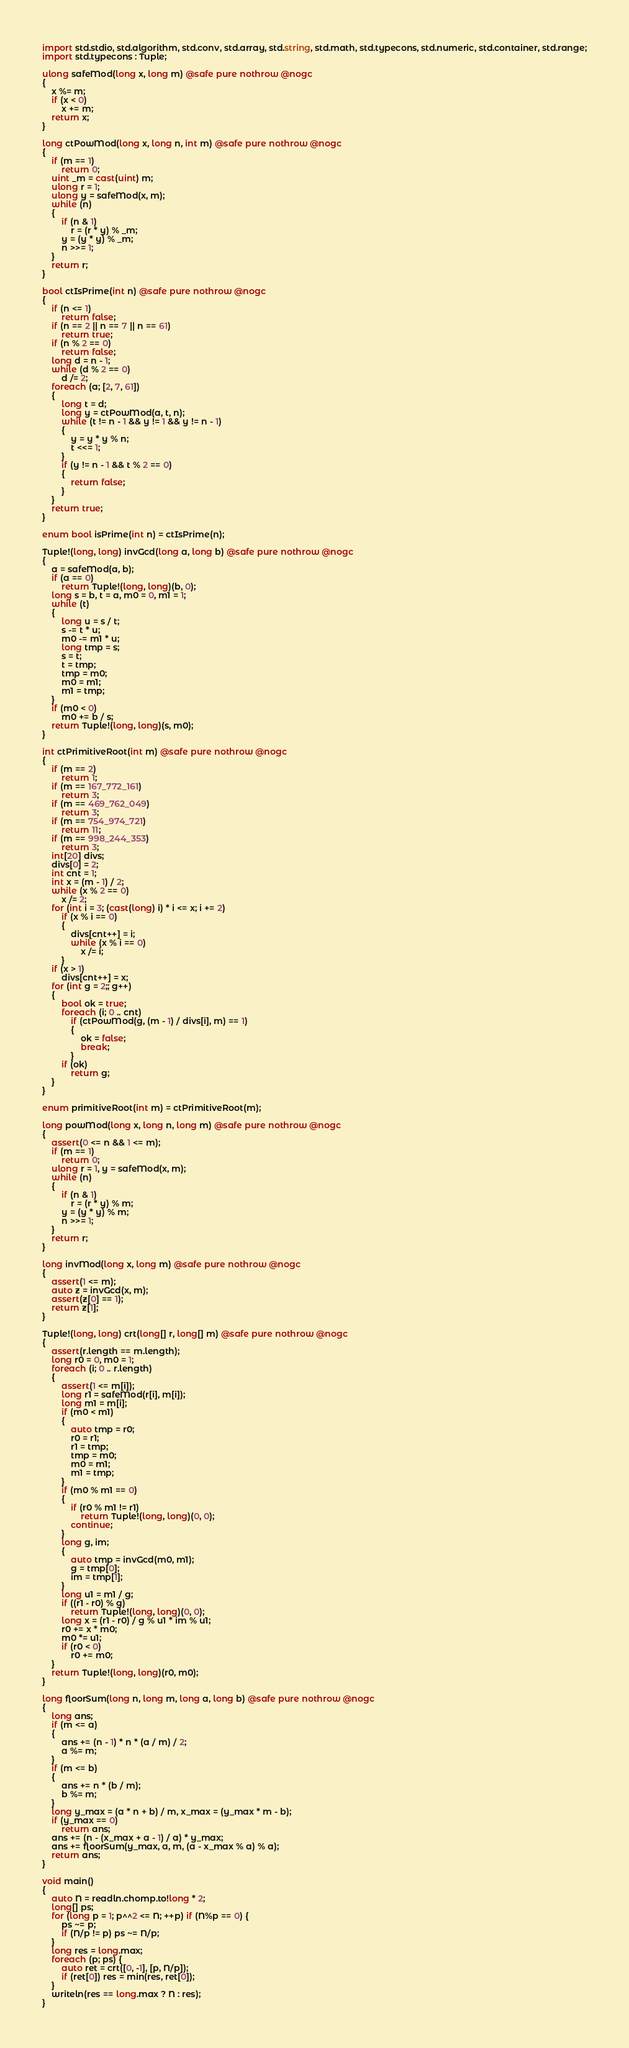Convert code to text. <code><loc_0><loc_0><loc_500><loc_500><_D_>import std.stdio, std.algorithm, std.conv, std.array, std.string, std.math, std.typecons, std.numeric, std.container, std.range;
import std.typecons : Tuple;

ulong safeMod(long x, long m) @safe pure nothrow @nogc
{
    x %= m;
    if (x < 0)
        x += m;
    return x;
}

long ctPowMod(long x, long n, int m) @safe pure nothrow @nogc
{
    if (m == 1)
        return 0;
    uint _m = cast(uint) m;
    ulong r = 1;
    ulong y = safeMod(x, m);
    while (n)
    {
        if (n & 1)
            r = (r * y) % _m;
        y = (y * y) % _m;
        n >>= 1;
    }
    return r;
}

bool ctIsPrime(int n) @safe pure nothrow @nogc
{
    if (n <= 1)
        return false;
    if (n == 2 || n == 7 || n == 61)
        return true;
    if (n % 2 == 0)
        return false;
    long d = n - 1;
    while (d % 2 == 0)
        d /= 2;
    foreach (a; [2, 7, 61])
    {
        long t = d;
        long y = ctPowMod(a, t, n);
        while (t != n - 1 && y != 1 && y != n - 1)
        {
            y = y * y % n;
            t <<= 1;
        }
        if (y != n - 1 && t % 2 == 0)
        {
            return false;
        }
    }
    return true;
}

enum bool isPrime(int n) = ctIsPrime(n);

Tuple!(long, long) invGcd(long a, long b) @safe pure nothrow @nogc
{
    a = safeMod(a, b);
    if (a == 0)
        return Tuple!(long, long)(b, 0);
    long s = b, t = a, m0 = 0, m1 = 1;
    while (t)
    {
        long u = s / t;
        s -= t * u;
        m0 -= m1 * u;
        long tmp = s;
        s = t;
        t = tmp;
        tmp = m0;
        m0 = m1;
        m1 = tmp;
    }
    if (m0 < 0)
        m0 += b / s;
    return Tuple!(long, long)(s, m0);
}

int ctPrimitiveRoot(int m) @safe pure nothrow @nogc
{
    if (m == 2)
        return 1;
    if (m == 167_772_161)
        return 3;
    if (m == 469_762_049)
        return 3;
    if (m == 754_974_721)
        return 11;
    if (m == 998_244_353)
        return 3;
    int[20] divs;
    divs[0] = 2;
    int cnt = 1;
    int x = (m - 1) / 2;
    while (x % 2 == 0)
        x /= 2;
    for (int i = 3; (cast(long) i) * i <= x; i += 2)
        if (x % i == 0)
        {
            divs[cnt++] = i;
            while (x % i == 0)
                x /= i;
        }
    if (x > 1)
        divs[cnt++] = x;
    for (int g = 2;; g++)
    {
        bool ok = true;
        foreach (i; 0 .. cnt)
            if (ctPowMod(g, (m - 1) / divs[i], m) == 1)
            {
                ok = false;
                break;
            }
        if (ok)
            return g;
    }
}

enum primitiveRoot(int m) = ctPrimitiveRoot(m);

long powMod(long x, long n, long m) @safe pure nothrow @nogc
{
    assert(0 <= n && 1 <= m);
    if (m == 1)
        return 0;
    ulong r = 1, y = safeMod(x, m);
    while (n)
    {
        if (n & 1)
            r = (r * y) % m;
        y = (y * y) % m;
        n >>= 1;
    }
    return r;
}

long invMod(long x, long m) @safe pure nothrow @nogc
{
    assert(1 <= m);
    auto z = invGcd(x, m);
    assert(z[0] == 1);
    return z[1];
}

Tuple!(long, long) crt(long[] r, long[] m) @safe pure nothrow @nogc
{
    assert(r.length == m.length);
    long r0 = 0, m0 = 1;
    foreach (i; 0 .. r.length)
    {
        assert(1 <= m[i]);
        long r1 = safeMod(r[i], m[i]);
        long m1 = m[i];
        if (m0 < m1)
        {
            auto tmp = r0;
            r0 = r1;
            r1 = tmp;
            tmp = m0;
            m0 = m1;
            m1 = tmp;
        }
        if (m0 % m1 == 0)
        {
            if (r0 % m1 != r1)
                return Tuple!(long, long)(0, 0);
            continue;
        }
        long g, im;
        {
            auto tmp = invGcd(m0, m1);
            g = tmp[0];
            im = tmp[1];
        }
        long u1 = m1 / g;
        if ((r1 - r0) % g)
            return Tuple!(long, long)(0, 0);
        long x = (r1 - r0) / g % u1 * im % u1;
        r0 += x * m0;
        m0 *= u1;
        if (r0 < 0)
            r0 += m0;
    }
    return Tuple!(long, long)(r0, m0);
}

long floorSum(long n, long m, long a, long b) @safe pure nothrow @nogc
{
    long ans;
    if (m <= a)
    {
        ans += (n - 1) * n * (a / m) / 2;
        a %= m;
    }
    if (m <= b)
    {
        ans += n * (b / m);
        b %= m;
    }
    long y_max = (a * n + b) / m, x_max = (y_max * m - b);
    if (y_max == 0)
        return ans;
    ans += (n - (x_max + a - 1) / a) * y_max;
    ans += floorSum(y_max, a, m, (a - x_max % a) % a);
    return ans;
}

void main()
{
    auto N = readln.chomp.to!long * 2;
    long[] ps;
    for (long p = 1; p^^2 <= N; ++p) if (N%p == 0) {
        ps ~= p;
        if (N/p != p) ps ~= N/p;
    }
    long res = long.max;
    foreach (p; ps) {
        auto ret = crt([0, -1], [p, N/p]);
        if (ret[0]) res = min(res, ret[0]);
    }
    writeln(res == long.max ? N : res);
}</code> 